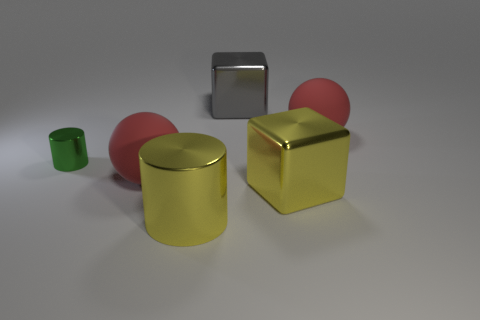There is a yellow cube; is it the same size as the ball that is on the right side of the big gray object?
Your answer should be very brief. Yes. There is a metal cylinder that is left of the big object on the left side of the yellow cylinder; are there any large yellow things that are behind it?
Your answer should be very brief. No. What is the yellow thing right of the large yellow shiny object that is on the left side of the big gray block made of?
Your response must be concise. Metal. What material is the object that is behind the green cylinder and in front of the large gray metal object?
Offer a very short reply. Rubber. Is there a gray object that has the same shape as the green metal object?
Your answer should be very brief. No. Is there a cube that is on the left side of the big red matte sphere to the left of the gray block?
Your answer should be very brief. No. How many yellow objects are made of the same material as the big cylinder?
Provide a succinct answer. 1. Is there a small yellow rubber cylinder?
Keep it short and to the point. No. What number of large blocks have the same color as the big metal cylinder?
Offer a very short reply. 1. Is the material of the small green thing the same as the red object behind the green thing?
Offer a very short reply. No. 